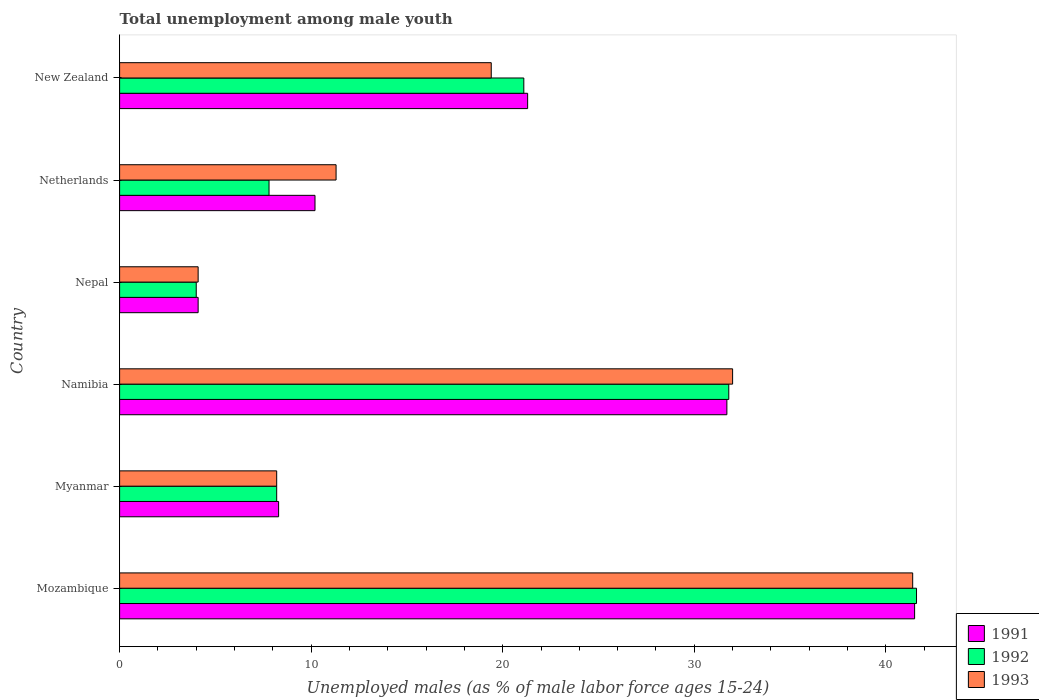How many different coloured bars are there?
Keep it short and to the point. 3. How many groups of bars are there?
Your response must be concise. 6. Are the number of bars per tick equal to the number of legend labels?
Your answer should be compact. Yes. Are the number of bars on each tick of the Y-axis equal?
Make the answer very short. Yes. How many bars are there on the 3rd tick from the top?
Make the answer very short. 3. How many bars are there on the 4th tick from the bottom?
Your answer should be very brief. 3. What is the label of the 6th group of bars from the top?
Your response must be concise. Mozambique. What is the percentage of unemployed males in in 1991 in Myanmar?
Offer a terse response. 8.3. Across all countries, what is the maximum percentage of unemployed males in in 1993?
Offer a very short reply. 41.4. Across all countries, what is the minimum percentage of unemployed males in in 1991?
Your response must be concise. 4.1. In which country was the percentage of unemployed males in in 1991 maximum?
Your answer should be compact. Mozambique. In which country was the percentage of unemployed males in in 1991 minimum?
Provide a succinct answer. Nepal. What is the total percentage of unemployed males in in 1992 in the graph?
Make the answer very short. 114.5. What is the difference between the percentage of unemployed males in in 1993 in Nepal and that in Netherlands?
Your response must be concise. -7.2. What is the difference between the percentage of unemployed males in in 1992 in Myanmar and the percentage of unemployed males in in 1993 in Nepal?
Keep it short and to the point. 4.1. What is the average percentage of unemployed males in in 1992 per country?
Offer a terse response. 19.08. What is the difference between the percentage of unemployed males in in 1991 and percentage of unemployed males in in 1992 in Mozambique?
Provide a short and direct response. -0.1. In how many countries, is the percentage of unemployed males in in 1992 greater than 38 %?
Make the answer very short. 1. What is the ratio of the percentage of unemployed males in in 1992 in Mozambique to that in Myanmar?
Provide a short and direct response. 5.07. Is the percentage of unemployed males in in 1992 in Myanmar less than that in Netherlands?
Give a very brief answer. No. What is the difference between the highest and the second highest percentage of unemployed males in in 1992?
Your answer should be very brief. 9.8. What is the difference between the highest and the lowest percentage of unemployed males in in 1992?
Provide a short and direct response. 37.6. In how many countries, is the percentage of unemployed males in in 1992 greater than the average percentage of unemployed males in in 1992 taken over all countries?
Provide a succinct answer. 3. Is the sum of the percentage of unemployed males in in 1992 in Myanmar and Netherlands greater than the maximum percentage of unemployed males in in 1993 across all countries?
Ensure brevity in your answer.  No. Is it the case that in every country, the sum of the percentage of unemployed males in in 1992 and percentage of unemployed males in in 1991 is greater than the percentage of unemployed males in in 1993?
Offer a terse response. Yes. How many bars are there?
Give a very brief answer. 18. Are the values on the major ticks of X-axis written in scientific E-notation?
Offer a very short reply. No. Does the graph contain any zero values?
Offer a terse response. No. How are the legend labels stacked?
Provide a short and direct response. Vertical. What is the title of the graph?
Provide a succinct answer. Total unemployment among male youth. Does "1984" appear as one of the legend labels in the graph?
Keep it short and to the point. No. What is the label or title of the X-axis?
Your response must be concise. Unemployed males (as % of male labor force ages 15-24). What is the Unemployed males (as % of male labor force ages 15-24) of 1991 in Mozambique?
Give a very brief answer. 41.5. What is the Unemployed males (as % of male labor force ages 15-24) in 1992 in Mozambique?
Provide a short and direct response. 41.6. What is the Unemployed males (as % of male labor force ages 15-24) in 1993 in Mozambique?
Make the answer very short. 41.4. What is the Unemployed males (as % of male labor force ages 15-24) of 1991 in Myanmar?
Give a very brief answer. 8.3. What is the Unemployed males (as % of male labor force ages 15-24) of 1992 in Myanmar?
Give a very brief answer. 8.2. What is the Unemployed males (as % of male labor force ages 15-24) of 1993 in Myanmar?
Provide a succinct answer. 8.2. What is the Unemployed males (as % of male labor force ages 15-24) of 1991 in Namibia?
Your response must be concise. 31.7. What is the Unemployed males (as % of male labor force ages 15-24) in 1992 in Namibia?
Your answer should be compact. 31.8. What is the Unemployed males (as % of male labor force ages 15-24) in 1991 in Nepal?
Give a very brief answer. 4.1. What is the Unemployed males (as % of male labor force ages 15-24) in 1992 in Nepal?
Provide a short and direct response. 4. What is the Unemployed males (as % of male labor force ages 15-24) of 1993 in Nepal?
Ensure brevity in your answer.  4.1. What is the Unemployed males (as % of male labor force ages 15-24) in 1991 in Netherlands?
Ensure brevity in your answer.  10.2. What is the Unemployed males (as % of male labor force ages 15-24) in 1992 in Netherlands?
Ensure brevity in your answer.  7.8. What is the Unemployed males (as % of male labor force ages 15-24) of 1993 in Netherlands?
Give a very brief answer. 11.3. What is the Unemployed males (as % of male labor force ages 15-24) in 1991 in New Zealand?
Provide a short and direct response. 21.3. What is the Unemployed males (as % of male labor force ages 15-24) in 1992 in New Zealand?
Offer a very short reply. 21.1. What is the Unemployed males (as % of male labor force ages 15-24) in 1993 in New Zealand?
Make the answer very short. 19.4. Across all countries, what is the maximum Unemployed males (as % of male labor force ages 15-24) of 1991?
Your answer should be very brief. 41.5. Across all countries, what is the maximum Unemployed males (as % of male labor force ages 15-24) in 1992?
Your answer should be compact. 41.6. Across all countries, what is the maximum Unemployed males (as % of male labor force ages 15-24) of 1993?
Your answer should be compact. 41.4. Across all countries, what is the minimum Unemployed males (as % of male labor force ages 15-24) of 1991?
Your answer should be very brief. 4.1. Across all countries, what is the minimum Unemployed males (as % of male labor force ages 15-24) of 1992?
Provide a succinct answer. 4. Across all countries, what is the minimum Unemployed males (as % of male labor force ages 15-24) in 1993?
Offer a terse response. 4.1. What is the total Unemployed males (as % of male labor force ages 15-24) in 1991 in the graph?
Offer a terse response. 117.1. What is the total Unemployed males (as % of male labor force ages 15-24) in 1992 in the graph?
Give a very brief answer. 114.5. What is the total Unemployed males (as % of male labor force ages 15-24) in 1993 in the graph?
Offer a terse response. 116.4. What is the difference between the Unemployed males (as % of male labor force ages 15-24) of 1991 in Mozambique and that in Myanmar?
Your response must be concise. 33.2. What is the difference between the Unemployed males (as % of male labor force ages 15-24) in 1992 in Mozambique and that in Myanmar?
Offer a very short reply. 33.4. What is the difference between the Unemployed males (as % of male labor force ages 15-24) of 1993 in Mozambique and that in Myanmar?
Make the answer very short. 33.2. What is the difference between the Unemployed males (as % of male labor force ages 15-24) of 1991 in Mozambique and that in Namibia?
Provide a succinct answer. 9.8. What is the difference between the Unemployed males (as % of male labor force ages 15-24) in 1993 in Mozambique and that in Namibia?
Make the answer very short. 9.4. What is the difference between the Unemployed males (as % of male labor force ages 15-24) in 1991 in Mozambique and that in Nepal?
Your answer should be compact. 37.4. What is the difference between the Unemployed males (as % of male labor force ages 15-24) in 1992 in Mozambique and that in Nepal?
Offer a terse response. 37.6. What is the difference between the Unemployed males (as % of male labor force ages 15-24) in 1993 in Mozambique and that in Nepal?
Make the answer very short. 37.3. What is the difference between the Unemployed males (as % of male labor force ages 15-24) in 1991 in Mozambique and that in Netherlands?
Keep it short and to the point. 31.3. What is the difference between the Unemployed males (as % of male labor force ages 15-24) of 1992 in Mozambique and that in Netherlands?
Your response must be concise. 33.8. What is the difference between the Unemployed males (as % of male labor force ages 15-24) of 1993 in Mozambique and that in Netherlands?
Make the answer very short. 30.1. What is the difference between the Unemployed males (as % of male labor force ages 15-24) of 1991 in Mozambique and that in New Zealand?
Your response must be concise. 20.2. What is the difference between the Unemployed males (as % of male labor force ages 15-24) in 1991 in Myanmar and that in Namibia?
Your answer should be compact. -23.4. What is the difference between the Unemployed males (as % of male labor force ages 15-24) in 1992 in Myanmar and that in Namibia?
Your response must be concise. -23.6. What is the difference between the Unemployed males (as % of male labor force ages 15-24) in 1993 in Myanmar and that in Namibia?
Make the answer very short. -23.8. What is the difference between the Unemployed males (as % of male labor force ages 15-24) in 1991 in Myanmar and that in Nepal?
Ensure brevity in your answer.  4.2. What is the difference between the Unemployed males (as % of male labor force ages 15-24) of 1991 in Myanmar and that in Netherlands?
Ensure brevity in your answer.  -1.9. What is the difference between the Unemployed males (as % of male labor force ages 15-24) of 1992 in Myanmar and that in Netherlands?
Give a very brief answer. 0.4. What is the difference between the Unemployed males (as % of male labor force ages 15-24) in 1992 in Myanmar and that in New Zealand?
Your answer should be compact. -12.9. What is the difference between the Unemployed males (as % of male labor force ages 15-24) of 1991 in Namibia and that in Nepal?
Make the answer very short. 27.6. What is the difference between the Unemployed males (as % of male labor force ages 15-24) in 1992 in Namibia and that in Nepal?
Offer a very short reply. 27.8. What is the difference between the Unemployed males (as % of male labor force ages 15-24) of 1993 in Namibia and that in Nepal?
Give a very brief answer. 27.9. What is the difference between the Unemployed males (as % of male labor force ages 15-24) of 1991 in Namibia and that in Netherlands?
Provide a succinct answer. 21.5. What is the difference between the Unemployed males (as % of male labor force ages 15-24) in 1992 in Namibia and that in Netherlands?
Ensure brevity in your answer.  24. What is the difference between the Unemployed males (as % of male labor force ages 15-24) in 1993 in Namibia and that in Netherlands?
Your response must be concise. 20.7. What is the difference between the Unemployed males (as % of male labor force ages 15-24) of 1991 in Namibia and that in New Zealand?
Ensure brevity in your answer.  10.4. What is the difference between the Unemployed males (as % of male labor force ages 15-24) in 1992 in Namibia and that in New Zealand?
Your answer should be very brief. 10.7. What is the difference between the Unemployed males (as % of male labor force ages 15-24) in 1993 in Namibia and that in New Zealand?
Your answer should be very brief. 12.6. What is the difference between the Unemployed males (as % of male labor force ages 15-24) of 1991 in Nepal and that in Netherlands?
Offer a very short reply. -6.1. What is the difference between the Unemployed males (as % of male labor force ages 15-24) of 1992 in Nepal and that in Netherlands?
Provide a short and direct response. -3.8. What is the difference between the Unemployed males (as % of male labor force ages 15-24) of 1993 in Nepal and that in Netherlands?
Provide a short and direct response. -7.2. What is the difference between the Unemployed males (as % of male labor force ages 15-24) of 1991 in Nepal and that in New Zealand?
Your response must be concise. -17.2. What is the difference between the Unemployed males (as % of male labor force ages 15-24) in 1992 in Nepal and that in New Zealand?
Give a very brief answer. -17.1. What is the difference between the Unemployed males (as % of male labor force ages 15-24) in 1993 in Nepal and that in New Zealand?
Provide a succinct answer. -15.3. What is the difference between the Unemployed males (as % of male labor force ages 15-24) in 1991 in Mozambique and the Unemployed males (as % of male labor force ages 15-24) in 1992 in Myanmar?
Provide a succinct answer. 33.3. What is the difference between the Unemployed males (as % of male labor force ages 15-24) of 1991 in Mozambique and the Unemployed males (as % of male labor force ages 15-24) of 1993 in Myanmar?
Ensure brevity in your answer.  33.3. What is the difference between the Unemployed males (as % of male labor force ages 15-24) in 1992 in Mozambique and the Unemployed males (as % of male labor force ages 15-24) in 1993 in Myanmar?
Your answer should be compact. 33.4. What is the difference between the Unemployed males (as % of male labor force ages 15-24) in 1991 in Mozambique and the Unemployed males (as % of male labor force ages 15-24) in 1992 in Namibia?
Give a very brief answer. 9.7. What is the difference between the Unemployed males (as % of male labor force ages 15-24) in 1991 in Mozambique and the Unemployed males (as % of male labor force ages 15-24) in 1992 in Nepal?
Make the answer very short. 37.5. What is the difference between the Unemployed males (as % of male labor force ages 15-24) of 1991 in Mozambique and the Unemployed males (as % of male labor force ages 15-24) of 1993 in Nepal?
Provide a short and direct response. 37.4. What is the difference between the Unemployed males (as % of male labor force ages 15-24) of 1992 in Mozambique and the Unemployed males (as % of male labor force ages 15-24) of 1993 in Nepal?
Offer a terse response. 37.5. What is the difference between the Unemployed males (as % of male labor force ages 15-24) of 1991 in Mozambique and the Unemployed males (as % of male labor force ages 15-24) of 1992 in Netherlands?
Offer a very short reply. 33.7. What is the difference between the Unemployed males (as % of male labor force ages 15-24) of 1991 in Mozambique and the Unemployed males (as % of male labor force ages 15-24) of 1993 in Netherlands?
Ensure brevity in your answer.  30.2. What is the difference between the Unemployed males (as % of male labor force ages 15-24) in 1992 in Mozambique and the Unemployed males (as % of male labor force ages 15-24) in 1993 in Netherlands?
Your answer should be compact. 30.3. What is the difference between the Unemployed males (as % of male labor force ages 15-24) of 1991 in Mozambique and the Unemployed males (as % of male labor force ages 15-24) of 1992 in New Zealand?
Offer a very short reply. 20.4. What is the difference between the Unemployed males (as % of male labor force ages 15-24) in 1991 in Mozambique and the Unemployed males (as % of male labor force ages 15-24) in 1993 in New Zealand?
Provide a short and direct response. 22.1. What is the difference between the Unemployed males (as % of male labor force ages 15-24) of 1991 in Myanmar and the Unemployed males (as % of male labor force ages 15-24) of 1992 in Namibia?
Your answer should be compact. -23.5. What is the difference between the Unemployed males (as % of male labor force ages 15-24) of 1991 in Myanmar and the Unemployed males (as % of male labor force ages 15-24) of 1993 in Namibia?
Your answer should be very brief. -23.7. What is the difference between the Unemployed males (as % of male labor force ages 15-24) of 1992 in Myanmar and the Unemployed males (as % of male labor force ages 15-24) of 1993 in Namibia?
Provide a succinct answer. -23.8. What is the difference between the Unemployed males (as % of male labor force ages 15-24) in 1991 in Myanmar and the Unemployed males (as % of male labor force ages 15-24) in 1992 in Nepal?
Ensure brevity in your answer.  4.3. What is the difference between the Unemployed males (as % of male labor force ages 15-24) of 1991 in Myanmar and the Unemployed males (as % of male labor force ages 15-24) of 1993 in Nepal?
Offer a terse response. 4.2. What is the difference between the Unemployed males (as % of male labor force ages 15-24) of 1992 in Myanmar and the Unemployed males (as % of male labor force ages 15-24) of 1993 in Nepal?
Give a very brief answer. 4.1. What is the difference between the Unemployed males (as % of male labor force ages 15-24) of 1992 in Myanmar and the Unemployed males (as % of male labor force ages 15-24) of 1993 in Netherlands?
Your response must be concise. -3.1. What is the difference between the Unemployed males (as % of male labor force ages 15-24) of 1991 in Myanmar and the Unemployed males (as % of male labor force ages 15-24) of 1993 in New Zealand?
Your answer should be compact. -11.1. What is the difference between the Unemployed males (as % of male labor force ages 15-24) of 1991 in Namibia and the Unemployed males (as % of male labor force ages 15-24) of 1992 in Nepal?
Your answer should be compact. 27.7. What is the difference between the Unemployed males (as % of male labor force ages 15-24) of 1991 in Namibia and the Unemployed males (as % of male labor force ages 15-24) of 1993 in Nepal?
Your answer should be very brief. 27.6. What is the difference between the Unemployed males (as % of male labor force ages 15-24) of 1992 in Namibia and the Unemployed males (as % of male labor force ages 15-24) of 1993 in Nepal?
Make the answer very short. 27.7. What is the difference between the Unemployed males (as % of male labor force ages 15-24) of 1991 in Namibia and the Unemployed males (as % of male labor force ages 15-24) of 1992 in Netherlands?
Give a very brief answer. 23.9. What is the difference between the Unemployed males (as % of male labor force ages 15-24) in 1991 in Namibia and the Unemployed males (as % of male labor force ages 15-24) in 1993 in Netherlands?
Offer a terse response. 20.4. What is the difference between the Unemployed males (as % of male labor force ages 15-24) in 1992 in Namibia and the Unemployed males (as % of male labor force ages 15-24) in 1993 in Netherlands?
Offer a very short reply. 20.5. What is the difference between the Unemployed males (as % of male labor force ages 15-24) of 1991 in Namibia and the Unemployed males (as % of male labor force ages 15-24) of 1992 in New Zealand?
Keep it short and to the point. 10.6. What is the difference between the Unemployed males (as % of male labor force ages 15-24) of 1991 in Nepal and the Unemployed males (as % of male labor force ages 15-24) of 1993 in Netherlands?
Provide a short and direct response. -7.2. What is the difference between the Unemployed males (as % of male labor force ages 15-24) in 1992 in Nepal and the Unemployed males (as % of male labor force ages 15-24) in 1993 in Netherlands?
Your answer should be very brief. -7.3. What is the difference between the Unemployed males (as % of male labor force ages 15-24) of 1991 in Nepal and the Unemployed males (as % of male labor force ages 15-24) of 1993 in New Zealand?
Provide a succinct answer. -15.3. What is the difference between the Unemployed males (as % of male labor force ages 15-24) in 1992 in Nepal and the Unemployed males (as % of male labor force ages 15-24) in 1993 in New Zealand?
Give a very brief answer. -15.4. What is the average Unemployed males (as % of male labor force ages 15-24) in 1991 per country?
Give a very brief answer. 19.52. What is the average Unemployed males (as % of male labor force ages 15-24) in 1992 per country?
Your answer should be very brief. 19.08. What is the average Unemployed males (as % of male labor force ages 15-24) of 1993 per country?
Provide a succinct answer. 19.4. What is the difference between the Unemployed males (as % of male labor force ages 15-24) of 1991 and Unemployed males (as % of male labor force ages 15-24) of 1993 in Mozambique?
Give a very brief answer. 0.1. What is the difference between the Unemployed males (as % of male labor force ages 15-24) of 1992 and Unemployed males (as % of male labor force ages 15-24) of 1993 in Mozambique?
Ensure brevity in your answer.  0.2. What is the difference between the Unemployed males (as % of male labor force ages 15-24) in 1991 and Unemployed males (as % of male labor force ages 15-24) in 1992 in Namibia?
Provide a short and direct response. -0.1. What is the difference between the Unemployed males (as % of male labor force ages 15-24) in 1991 and Unemployed males (as % of male labor force ages 15-24) in 1992 in Nepal?
Your response must be concise. 0.1. What is the difference between the Unemployed males (as % of male labor force ages 15-24) in 1992 and Unemployed males (as % of male labor force ages 15-24) in 1993 in New Zealand?
Your answer should be very brief. 1.7. What is the ratio of the Unemployed males (as % of male labor force ages 15-24) of 1991 in Mozambique to that in Myanmar?
Keep it short and to the point. 5. What is the ratio of the Unemployed males (as % of male labor force ages 15-24) in 1992 in Mozambique to that in Myanmar?
Offer a terse response. 5.07. What is the ratio of the Unemployed males (as % of male labor force ages 15-24) in 1993 in Mozambique to that in Myanmar?
Ensure brevity in your answer.  5.05. What is the ratio of the Unemployed males (as % of male labor force ages 15-24) in 1991 in Mozambique to that in Namibia?
Provide a succinct answer. 1.31. What is the ratio of the Unemployed males (as % of male labor force ages 15-24) in 1992 in Mozambique to that in Namibia?
Make the answer very short. 1.31. What is the ratio of the Unemployed males (as % of male labor force ages 15-24) in 1993 in Mozambique to that in Namibia?
Offer a very short reply. 1.29. What is the ratio of the Unemployed males (as % of male labor force ages 15-24) in 1991 in Mozambique to that in Nepal?
Offer a very short reply. 10.12. What is the ratio of the Unemployed males (as % of male labor force ages 15-24) in 1992 in Mozambique to that in Nepal?
Ensure brevity in your answer.  10.4. What is the ratio of the Unemployed males (as % of male labor force ages 15-24) of 1993 in Mozambique to that in Nepal?
Keep it short and to the point. 10.1. What is the ratio of the Unemployed males (as % of male labor force ages 15-24) of 1991 in Mozambique to that in Netherlands?
Keep it short and to the point. 4.07. What is the ratio of the Unemployed males (as % of male labor force ages 15-24) of 1992 in Mozambique to that in Netherlands?
Provide a succinct answer. 5.33. What is the ratio of the Unemployed males (as % of male labor force ages 15-24) of 1993 in Mozambique to that in Netherlands?
Provide a succinct answer. 3.66. What is the ratio of the Unemployed males (as % of male labor force ages 15-24) of 1991 in Mozambique to that in New Zealand?
Provide a short and direct response. 1.95. What is the ratio of the Unemployed males (as % of male labor force ages 15-24) of 1992 in Mozambique to that in New Zealand?
Your answer should be very brief. 1.97. What is the ratio of the Unemployed males (as % of male labor force ages 15-24) of 1993 in Mozambique to that in New Zealand?
Keep it short and to the point. 2.13. What is the ratio of the Unemployed males (as % of male labor force ages 15-24) of 1991 in Myanmar to that in Namibia?
Offer a very short reply. 0.26. What is the ratio of the Unemployed males (as % of male labor force ages 15-24) of 1992 in Myanmar to that in Namibia?
Provide a succinct answer. 0.26. What is the ratio of the Unemployed males (as % of male labor force ages 15-24) of 1993 in Myanmar to that in Namibia?
Ensure brevity in your answer.  0.26. What is the ratio of the Unemployed males (as % of male labor force ages 15-24) of 1991 in Myanmar to that in Nepal?
Make the answer very short. 2.02. What is the ratio of the Unemployed males (as % of male labor force ages 15-24) in 1992 in Myanmar to that in Nepal?
Your answer should be very brief. 2.05. What is the ratio of the Unemployed males (as % of male labor force ages 15-24) of 1991 in Myanmar to that in Netherlands?
Offer a very short reply. 0.81. What is the ratio of the Unemployed males (as % of male labor force ages 15-24) of 1992 in Myanmar to that in Netherlands?
Offer a terse response. 1.05. What is the ratio of the Unemployed males (as % of male labor force ages 15-24) of 1993 in Myanmar to that in Netherlands?
Keep it short and to the point. 0.73. What is the ratio of the Unemployed males (as % of male labor force ages 15-24) of 1991 in Myanmar to that in New Zealand?
Ensure brevity in your answer.  0.39. What is the ratio of the Unemployed males (as % of male labor force ages 15-24) of 1992 in Myanmar to that in New Zealand?
Make the answer very short. 0.39. What is the ratio of the Unemployed males (as % of male labor force ages 15-24) in 1993 in Myanmar to that in New Zealand?
Your answer should be very brief. 0.42. What is the ratio of the Unemployed males (as % of male labor force ages 15-24) in 1991 in Namibia to that in Nepal?
Make the answer very short. 7.73. What is the ratio of the Unemployed males (as % of male labor force ages 15-24) of 1992 in Namibia to that in Nepal?
Your answer should be very brief. 7.95. What is the ratio of the Unemployed males (as % of male labor force ages 15-24) of 1993 in Namibia to that in Nepal?
Your answer should be very brief. 7.8. What is the ratio of the Unemployed males (as % of male labor force ages 15-24) of 1991 in Namibia to that in Netherlands?
Ensure brevity in your answer.  3.11. What is the ratio of the Unemployed males (as % of male labor force ages 15-24) in 1992 in Namibia to that in Netherlands?
Keep it short and to the point. 4.08. What is the ratio of the Unemployed males (as % of male labor force ages 15-24) of 1993 in Namibia to that in Netherlands?
Give a very brief answer. 2.83. What is the ratio of the Unemployed males (as % of male labor force ages 15-24) of 1991 in Namibia to that in New Zealand?
Offer a very short reply. 1.49. What is the ratio of the Unemployed males (as % of male labor force ages 15-24) in 1992 in Namibia to that in New Zealand?
Offer a very short reply. 1.51. What is the ratio of the Unemployed males (as % of male labor force ages 15-24) of 1993 in Namibia to that in New Zealand?
Your response must be concise. 1.65. What is the ratio of the Unemployed males (as % of male labor force ages 15-24) in 1991 in Nepal to that in Netherlands?
Give a very brief answer. 0.4. What is the ratio of the Unemployed males (as % of male labor force ages 15-24) in 1992 in Nepal to that in Netherlands?
Provide a short and direct response. 0.51. What is the ratio of the Unemployed males (as % of male labor force ages 15-24) of 1993 in Nepal to that in Netherlands?
Keep it short and to the point. 0.36. What is the ratio of the Unemployed males (as % of male labor force ages 15-24) in 1991 in Nepal to that in New Zealand?
Your answer should be compact. 0.19. What is the ratio of the Unemployed males (as % of male labor force ages 15-24) in 1992 in Nepal to that in New Zealand?
Give a very brief answer. 0.19. What is the ratio of the Unemployed males (as % of male labor force ages 15-24) of 1993 in Nepal to that in New Zealand?
Your answer should be compact. 0.21. What is the ratio of the Unemployed males (as % of male labor force ages 15-24) in 1991 in Netherlands to that in New Zealand?
Provide a succinct answer. 0.48. What is the ratio of the Unemployed males (as % of male labor force ages 15-24) of 1992 in Netherlands to that in New Zealand?
Provide a succinct answer. 0.37. What is the ratio of the Unemployed males (as % of male labor force ages 15-24) of 1993 in Netherlands to that in New Zealand?
Provide a short and direct response. 0.58. What is the difference between the highest and the second highest Unemployed males (as % of male labor force ages 15-24) in 1992?
Give a very brief answer. 9.8. What is the difference between the highest and the second highest Unemployed males (as % of male labor force ages 15-24) of 1993?
Keep it short and to the point. 9.4. What is the difference between the highest and the lowest Unemployed males (as % of male labor force ages 15-24) in 1991?
Provide a short and direct response. 37.4. What is the difference between the highest and the lowest Unemployed males (as % of male labor force ages 15-24) in 1992?
Offer a very short reply. 37.6. What is the difference between the highest and the lowest Unemployed males (as % of male labor force ages 15-24) of 1993?
Give a very brief answer. 37.3. 